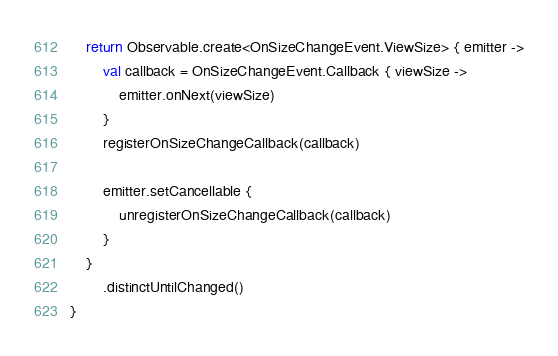<code> <loc_0><loc_0><loc_500><loc_500><_Kotlin_>    return Observable.create<OnSizeChangeEvent.ViewSize> { emitter ->
        val callback = OnSizeChangeEvent.Callback { viewSize ->
            emitter.onNext(viewSize)
        }
        registerOnSizeChangeCallback(callback)

        emitter.setCancellable {
            unregisterOnSizeChangeCallback(callback)
        }
    }
        .distinctUntilChanged()
}</code> 